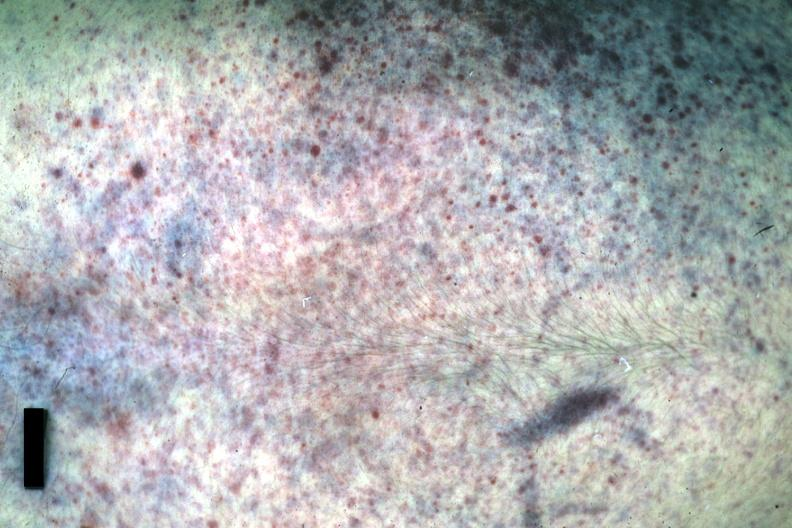was good example either chest anterior or posterior?
Answer the question using a single word or phrase. Yes 